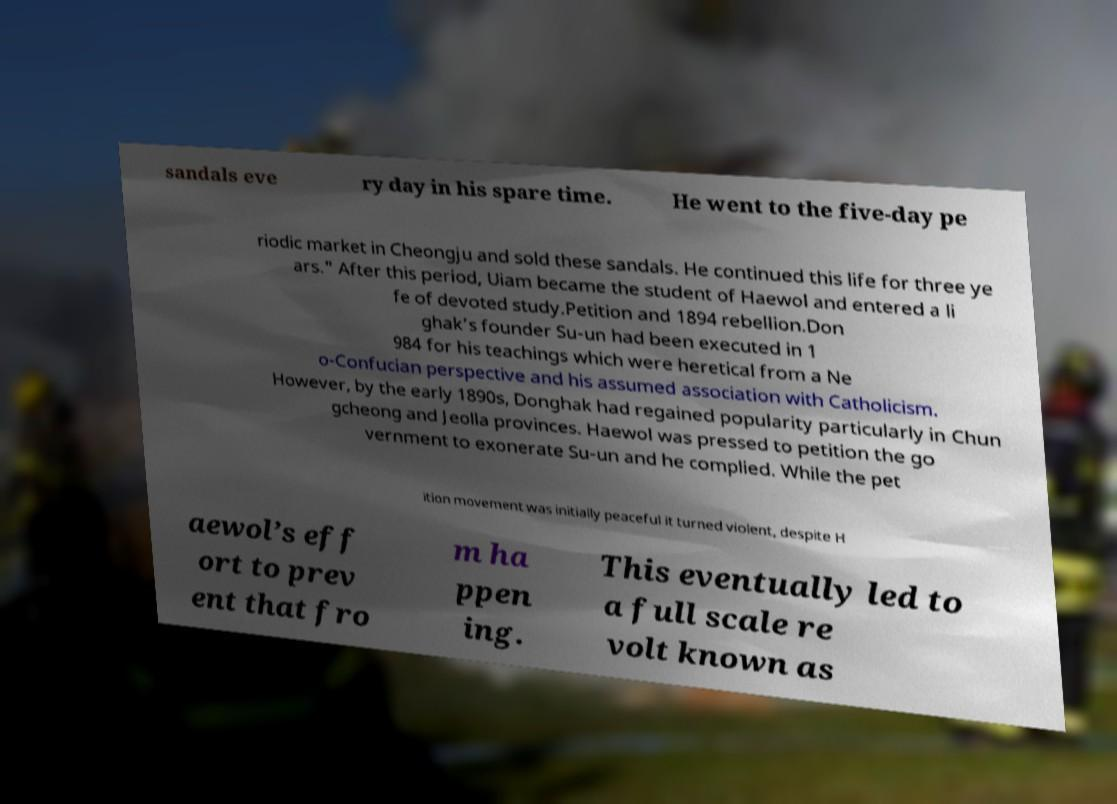There's text embedded in this image that I need extracted. Can you transcribe it verbatim? sandals eve ry day in his spare time. He went to the five-day pe riodic market in Cheongju and sold these sandals. He continued this life for three ye ars." After this period, Uiam became the student of Haewol and entered a li fe of devoted study.Petition and 1894 rebellion.Don ghak’s founder Su-un had been executed in 1 984 for his teachings which were heretical from a Ne o-Confucian perspective and his assumed association with Catholicism. However, by the early 1890s, Donghak had regained popularity particularly in Chun gcheong and Jeolla provinces. Haewol was pressed to petition the go vernment to exonerate Su-un and he complied. While the pet ition movement was initially peaceful it turned violent, despite H aewol’s eff ort to prev ent that fro m ha ppen ing. This eventually led to a full scale re volt known as 